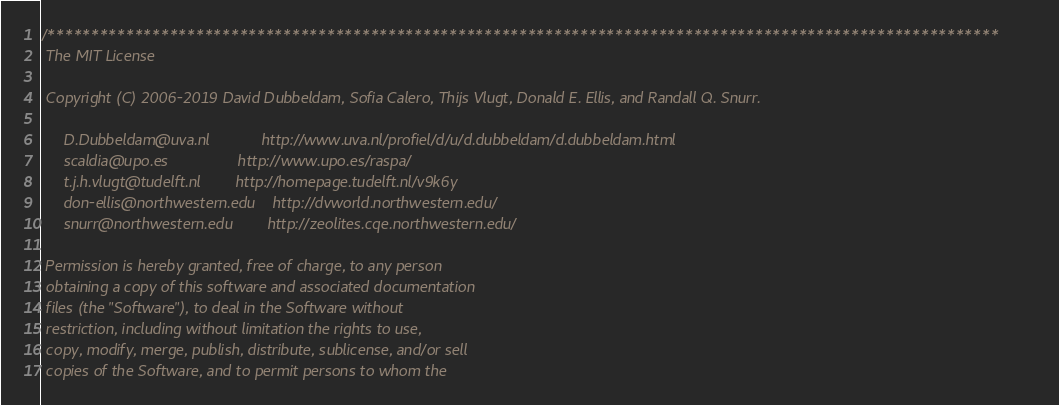Convert code to text. <code><loc_0><loc_0><loc_500><loc_500><_C_>/*************************************************************************************************************
 The MIT License

 Copyright (C) 2006-2019 David Dubbeldam, Sofia Calero, Thijs Vlugt, Donald E. Ellis, and Randall Q. Snurr.

     D.Dubbeldam@uva.nl            http://www.uva.nl/profiel/d/u/d.dubbeldam/d.dubbeldam.html
     scaldia@upo.es                http://www.upo.es/raspa/
     t.j.h.vlugt@tudelft.nl        http://homepage.tudelft.nl/v9k6y
     don-ellis@northwestern.edu    http://dvworld.northwestern.edu/
     snurr@northwestern.edu        http://zeolites.cqe.northwestern.edu/

 Permission is hereby granted, free of charge, to any person
 obtaining a copy of this software and associated documentation
 files (the "Software"), to deal in the Software without
 restriction, including without limitation the rights to use,
 copy, modify, merge, publish, distribute, sublicense, and/or sell
 copies of the Software, and to permit persons to whom the</code> 